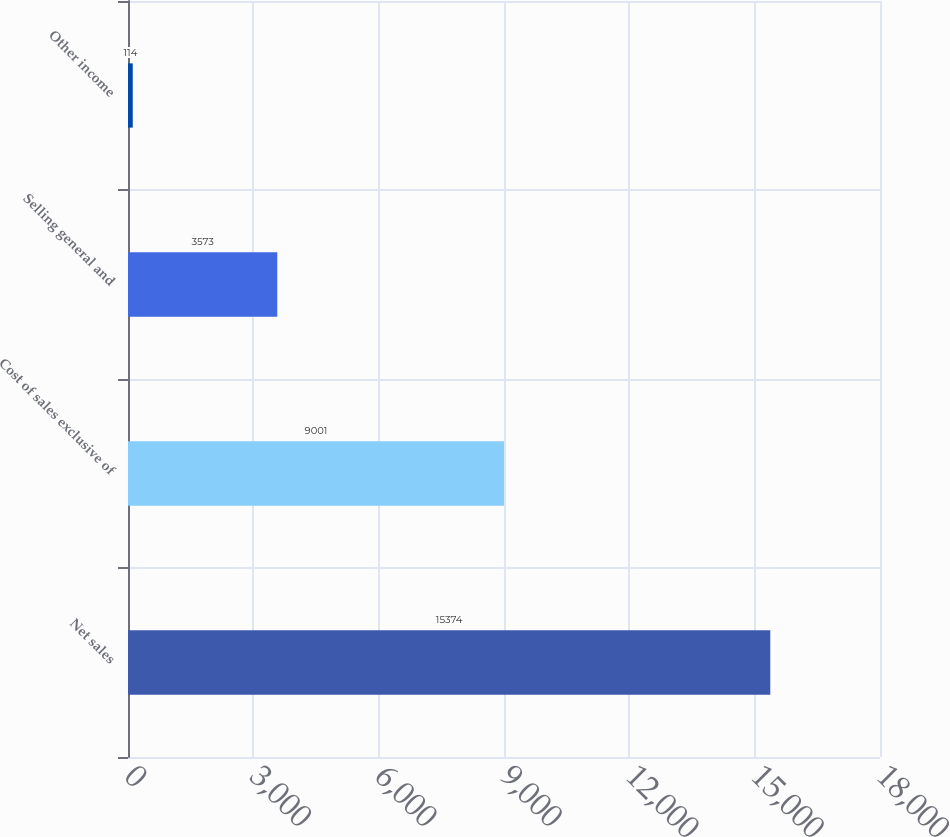Convert chart to OTSL. <chart><loc_0><loc_0><loc_500><loc_500><bar_chart><fcel>Net sales<fcel>Cost of sales exclusive of<fcel>Selling general and<fcel>Other income<nl><fcel>15374<fcel>9001<fcel>3573<fcel>114<nl></chart> 